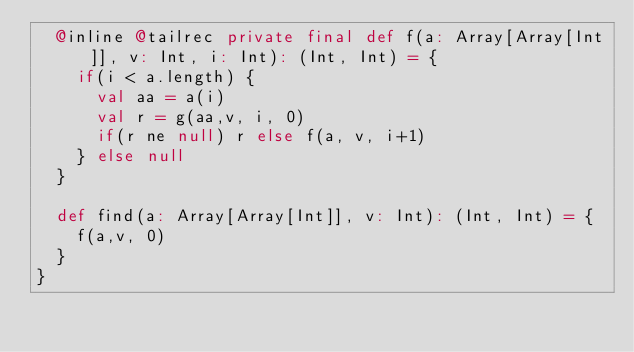<code> <loc_0><loc_0><loc_500><loc_500><_Scala_>  @inline @tailrec private final def f(a: Array[Array[Int]], v: Int, i: Int): (Int, Int) = {
    if(i < a.length) {
      val aa = a(i) 
      val r = g(aa,v, i, 0)
      if(r ne null) r else f(a, v, i+1)
    } else null
  }

  def find(a: Array[Array[Int]], v: Int): (Int, Int) = {
    f(a,v, 0)
  }
}
</code> 